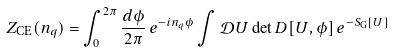<formula> <loc_0><loc_0><loc_500><loc_500>Z _ { \text {CE} } ( n _ { q } ) = \int _ { 0 } ^ { 2 \pi } \frac { d \phi } { 2 \pi } \, e ^ { - i n _ { q } \phi } \int \mathcal { D } U \det D [ U , \phi ] \, e ^ { - S _ { \text {G} } [ U ] }</formula> 